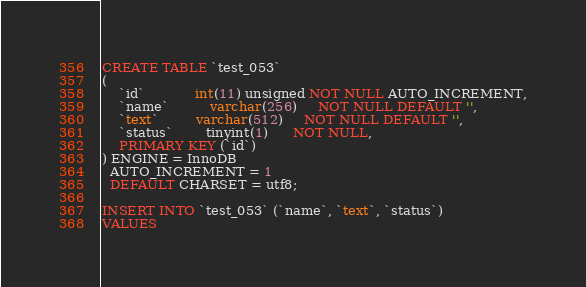<code> <loc_0><loc_0><loc_500><loc_500><_SQL_>CREATE TABLE `test_053`
(
    `id`            int(11) unsigned NOT NULL AUTO_INCREMENT,
    `name`          varchar(256)     NOT NULL DEFAULT '',
    `text`         varchar(512)     NOT NULL DEFAULT '',
    `status`        tinyint(1)      NOT NULL,
    PRIMARY KEY (`id`)
) ENGINE = InnoDB
  AUTO_INCREMENT = 1
  DEFAULT CHARSET = utf8;

INSERT INTO `test_053` (`name`, `text`, `status`)
VALUES</code> 